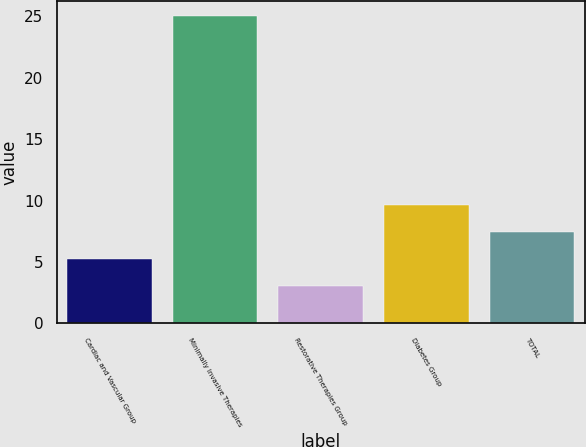<chart> <loc_0><loc_0><loc_500><loc_500><bar_chart><fcel>Cardiac and Vascular Group<fcel>Minimally Invasive Therapies<fcel>Restorative Therapies Group<fcel>Diabetes Group<fcel>TOTAL<nl><fcel>5.2<fcel>25<fcel>3<fcel>9.6<fcel>7.4<nl></chart> 